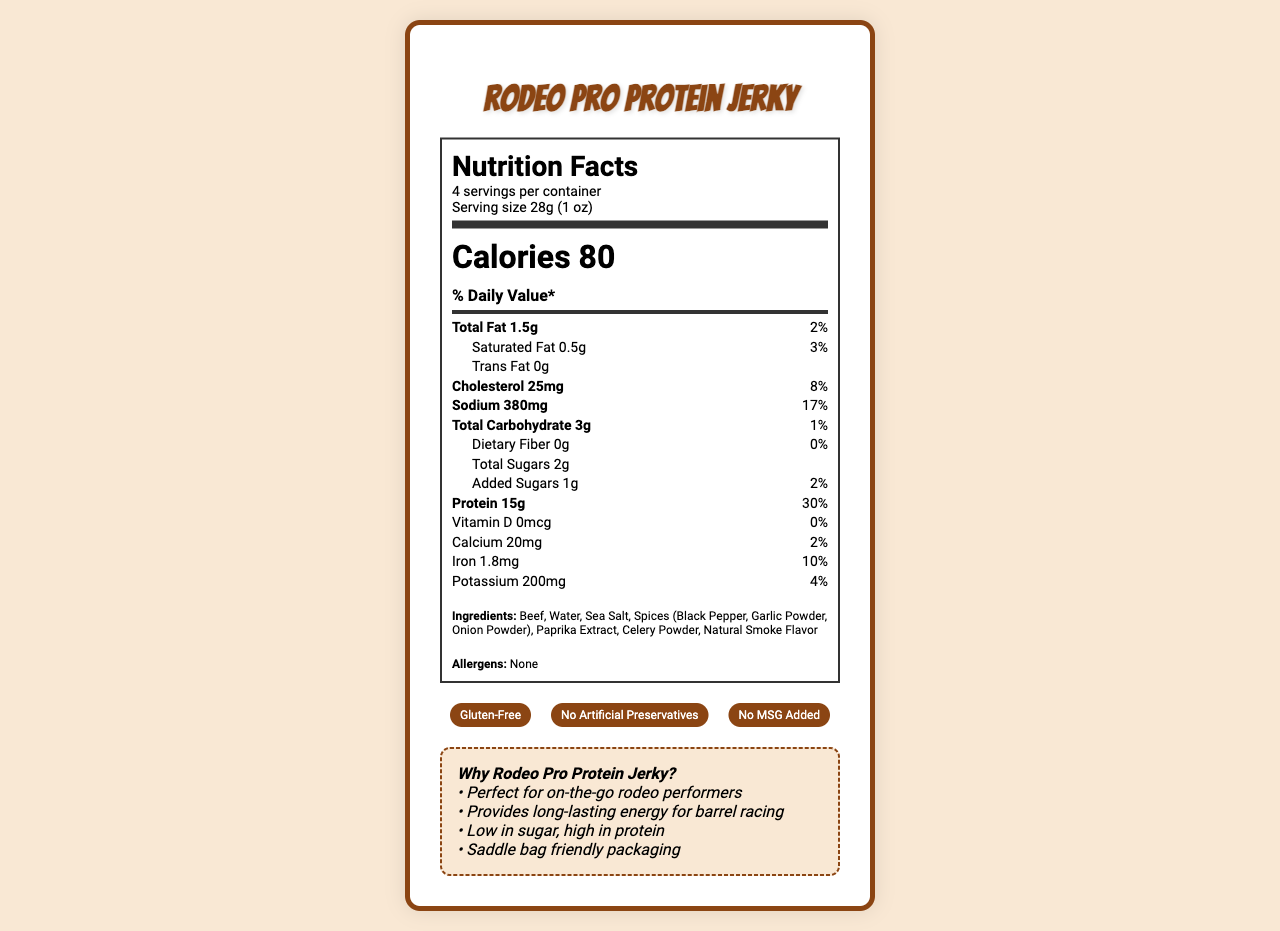what is the serving size of the Rodeo Pro Protein Jerky? The serving size is specified in the nutrition facts section as "28g (1 oz)".
Answer: 28g (1 oz) how many calories are in one serving? The calorie count per serving is listed under the Nutrition Facts heading as "Calories 80".
Answer: 80 calories what is the amount of total fat per serving? The total fat content per serving is mentioned directly under the daily value percentage as "Total Fat 1.5g".
Answer: 1.5g how much sodium does the product contain per serving? The sodium content per serving is stated as "Sodium 380mg".
Answer: 380mg what is the main source of protein in this snack? The main source of protein can be inferred from the first ingredient listed, which is "Beef".
Answer: Beef how many grams of protein are in one serving? The amount of protein per serving is specified as "Protein 15g".
Answer: 15g what percentage of the daily value of cholesterol does one serving provide? The percentage of the daily value for cholesterol is listed as "8%".
Answer: 8% are there any added sugars in this product? The document lists "Added Sugars 1g".
Answer: Yes how many servings are there in the entire container? The number of servings per container is noted as "4 servings per container".
Answer: 4 servings what is the daily value percentage for iron per serving? A. 2% B. 4% C. 10% D. 30% The daily value percentage for iron is given as "Iron 1.8mg 10%".
Answer: C. 10% which certification is NOT listed for the Rodeo Pro Protein Jerky? A. Gluten-Free B. Organic C. No MSG Added D. No Artificial Preservatives The certifications listed are "Gluten-Free", "No MSG Added", and "No Artificial Preservatives", but not "Organic".
Answer: B. Organic is this product suitable for someone with a gluten allergy? The product's certifications include "Gluten-Free".
Answer: Yes summarize the main idea of this document. This captures the summary by mentioning the key areas: nutrition facts, target market, and special attributes.
Answer: The document provides nutritional information, ingredients, certifications, and marketing claims for Rodeo Pro Protein Jerky, specifically targeted at rodeo performers. It's a low-sugar, high-protein snack designed to provide long-lasting energy and is marketed as gluten-free with no artificial preservatives or MSG. how many calories come from fat in one serving? The document does not specify the calories derived from fat alone; it only provides the total caloric content.
Answer: Not enough information what makes the packaging of this jerky special for rodeo performers? The marketing claims mention that the product comes in "Saddle bag friendly packaging", which highlights its convenience for rodeo performers.
Answer: Saddle bag friendly packaging 